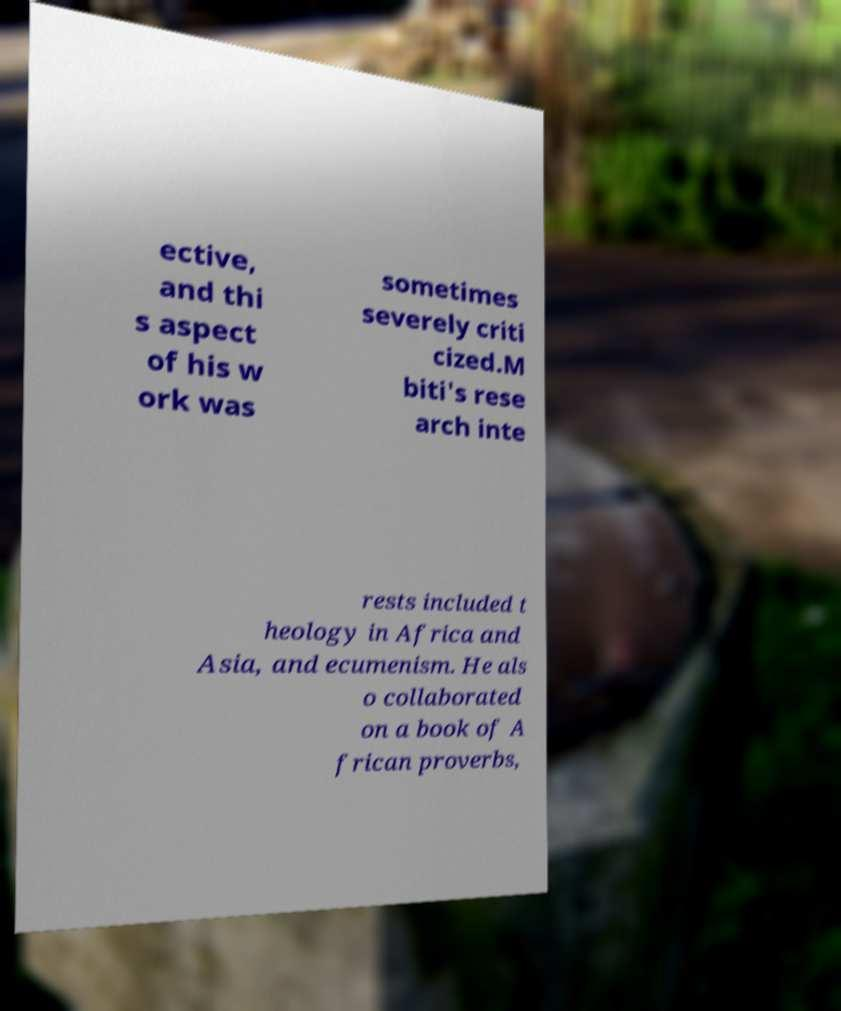What messages or text are displayed in this image? I need them in a readable, typed format. ective, and thi s aspect of his w ork was sometimes severely criti cized.M biti's rese arch inte rests included t heology in Africa and Asia, and ecumenism. He als o collaborated on a book of A frican proverbs, 